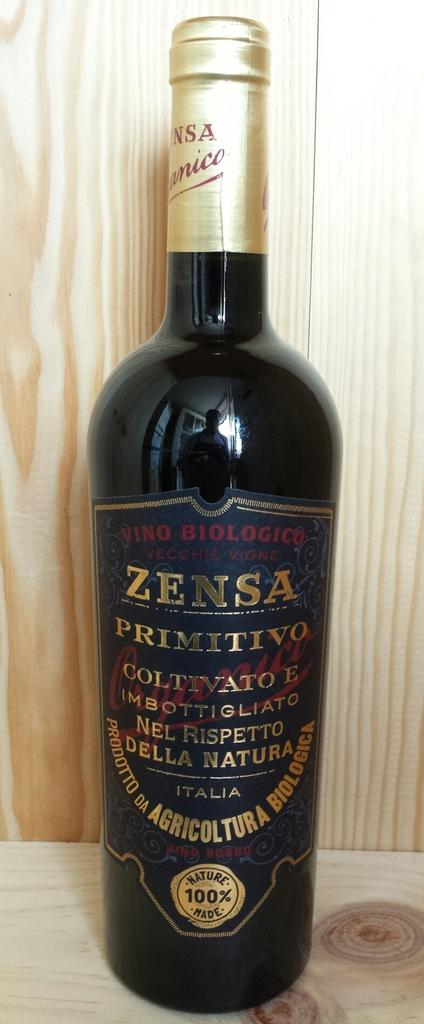<image>
Give a short and clear explanation of the subsequent image. A bottle of red wine with the name Zensa visible on the label. 